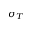Convert formula to latex. <formula><loc_0><loc_0><loc_500><loc_500>\sigma _ { T }</formula> 